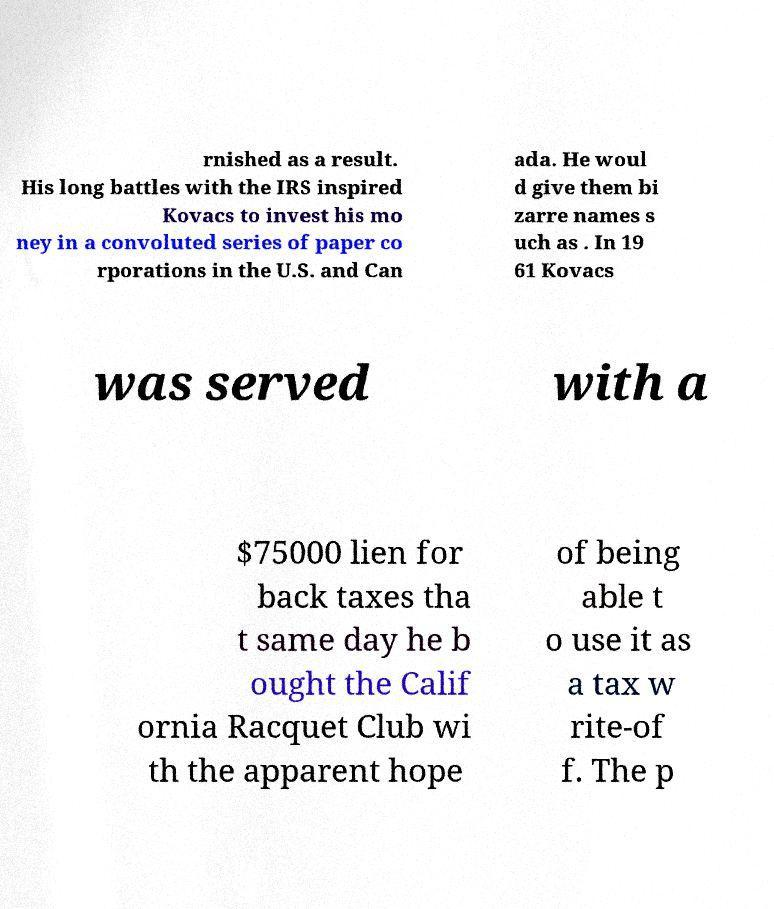For documentation purposes, I need the text within this image transcribed. Could you provide that? rnished as a result. His long battles with the IRS inspired Kovacs to invest his mo ney in a convoluted series of paper co rporations in the U.S. and Can ada. He woul d give them bi zarre names s uch as . In 19 61 Kovacs was served with a $75000 lien for back taxes tha t same day he b ought the Calif ornia Racquet Club wi th the apparent hope of being able t o use it as a tax w rite-of f. The p 